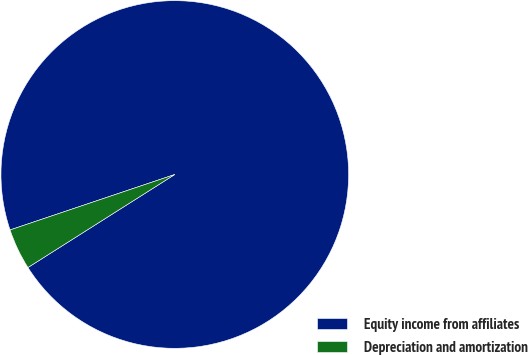<chart> <loc_0><loc_0><loc_500><loc_500><pie_chart><fcel>Equity income from affiliates<fcel>Depreciation and amortization<nl><fcel>96.18%<fcel>3.82%<nl></chart> 